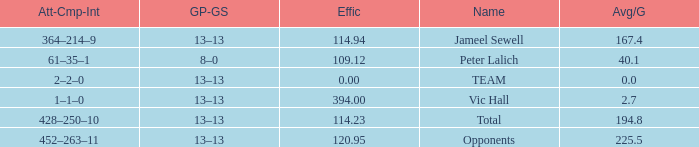Avg/G of 2.7 is what effic? 394.0. 